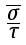<formula> <loc_0><loc_0><loc_500><loc_500>\begin{smallmatrix} \overline { \sigma } \\ \overline { \tau } \end{smallmatrix}</formula> 